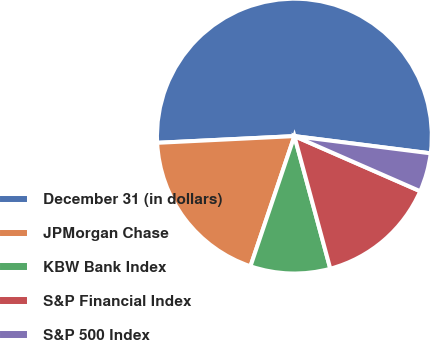Convert chart to OTSL. <chart><loc_0><loc_0><loc_500><loc_500><pie_chart><fcel>December 31 (in dollars)<fcel>JPMorgan Chase<fcel>KBW Bank Index<fcel>S&P Financial Index<fcel>S&P 500 Index<nl><fcel>52.78%<fcel>19.04%<fcel>9.39%<fcel>14.22%<fcel>4.57%<nl></chart> 